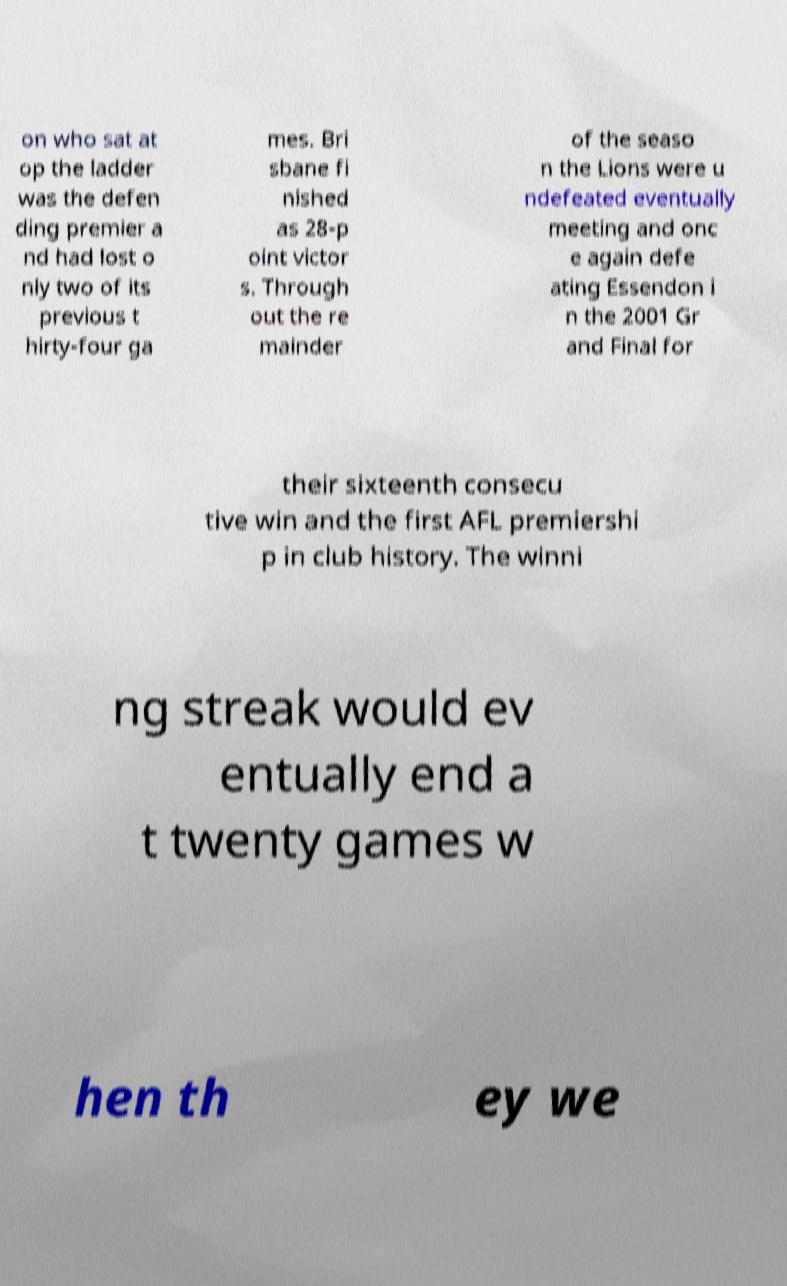Could you assist in decoding the text presented in this image and type it out clearly? on who sat at op the ladder was the defen ding premier a nd had lost o nly two of its previous t hirty-four ga mes. Bri sbane fi nished as 28-p oint victor s. Through out the re mainder of the seaso n the Lions were u ndefeated eventually meeting and onc e again defe ating Essendon i n the 2001 Gr and Final for their sixteenth consecu tive win and the first AFL premiershi p in club history. The winni ng streak would ev entually end a t twenty games w hen th ey we 